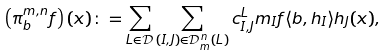<formula> <loc_0><loc_0><loc_500><loc_500>\left ( \pi ^ { m , n } _ { b } f \right ) ( x ) \colon = \sum _ { L \in \mathcal { D } } \sum _ { ( I , J ) \in \mathcal { D } ^ { n } _ { m } ( L ) } c ^ { L } _ { I , J } m _ { I } f \langle b , h _ { I } \rangle h _ { J } ( x ) ,</formula> 